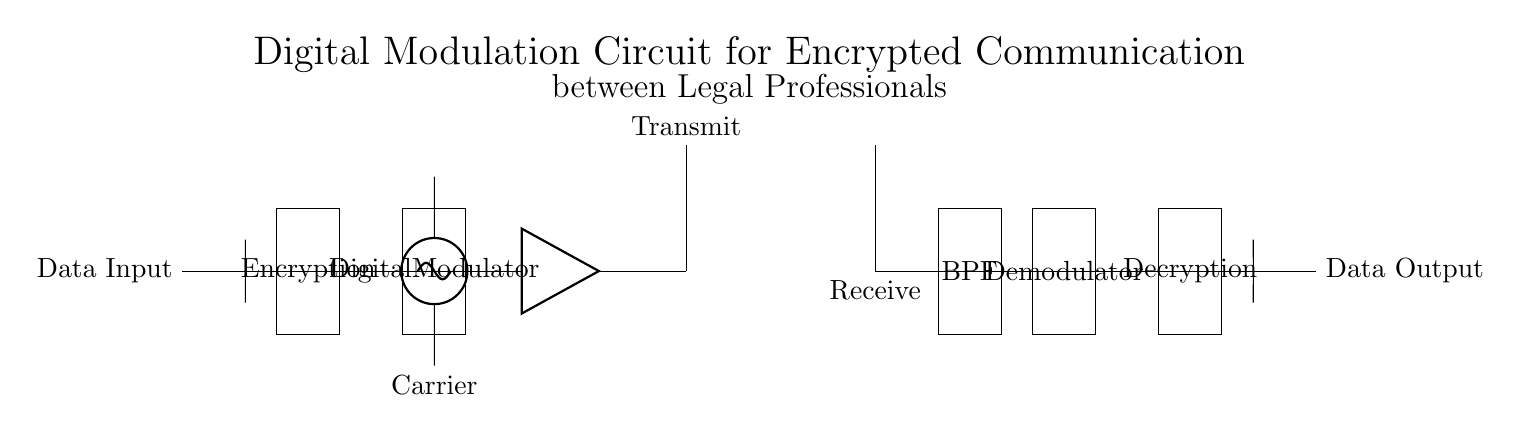What is the primary function of the encryption block? The encryption block's primary function is to secure the data before transmission, ensuring that the information is encoded and hidden from unauthorized access. This is inferred from its position in the circuit, directly after the data input.
Answer: Secure data What component generates the carrier frequency? The component generating the carrier frequency is the sinusoidal voltage source, as depicted in the circuit. It is shown connected to the digital modulator, which indicates that it is used to modulate the data.
Answer: Sinusoidal voltage source What is the purpose of the bandpass filter? The purpose of the bandpass filter is to allow only the specific frequency range of the received signal to pass through while blocking other frequencies. This is typical in communication systems to reduce noise and interference.
Answer: Allow specific frequencies What connects the digital modulator to the antenna? The component connecting the digital modulator to the antenna is the amplifier. It boosts the modulated signal's strength for better transmission. This can be confirmed by analyzing the direct line connecting the digital modulator to the amplifier, followed by the antenna.
Answer: Amplifier What follows the demodulator in the circuit? The component that follows the demodulator is the decryption block. This indicates that the demodulated signal is the input for decryption, restoring the data to its original form after transmission. This can be observed directly from the sequential connection in the circuit diagram.
Answer: Decryption 